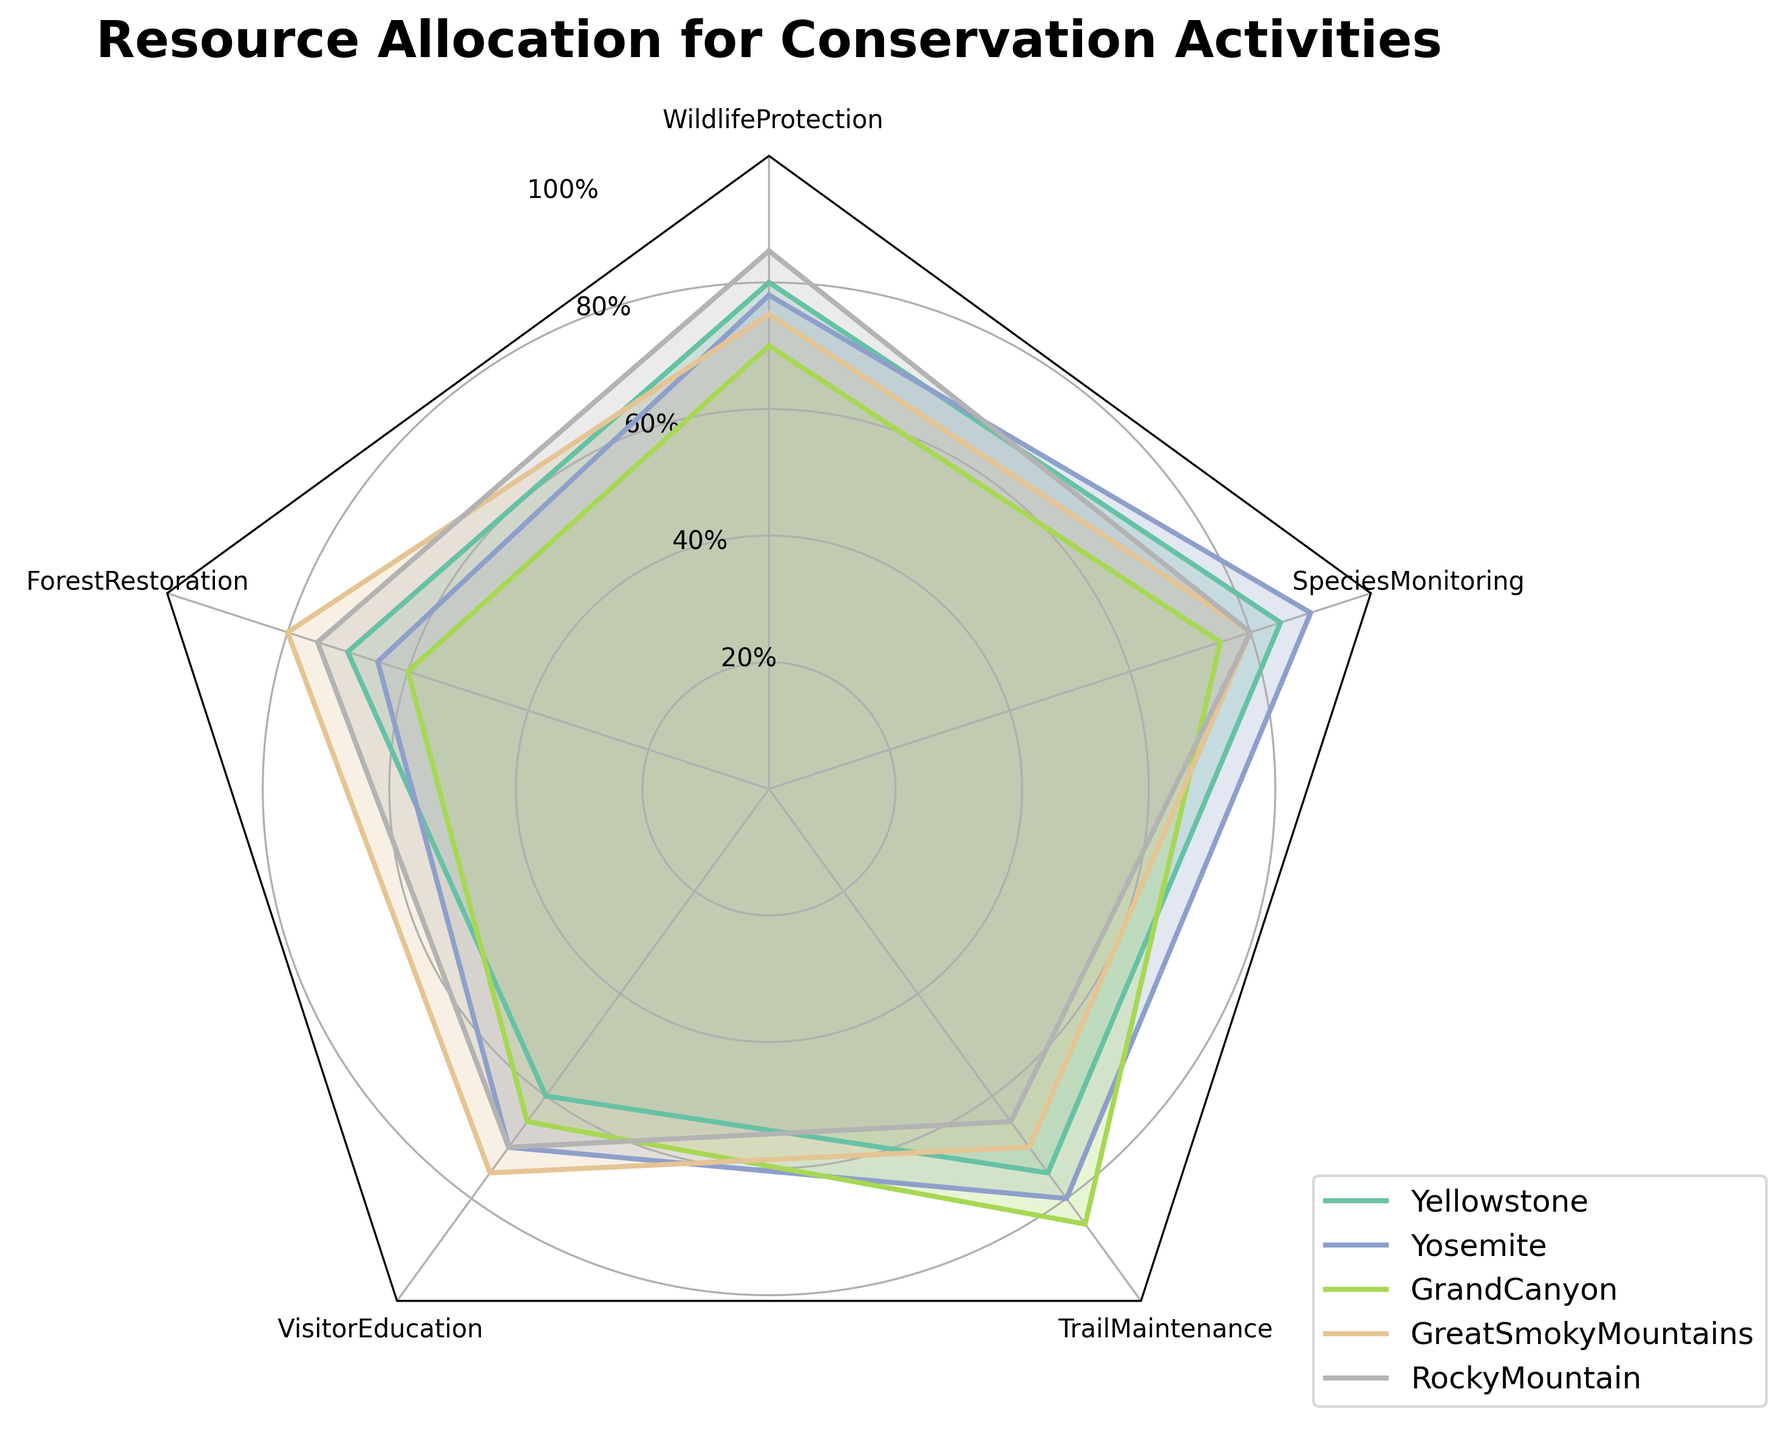How many activities are being allocated resources for conservation across the parks? The title indicates resource allocation for conservation activities and the radar chart has axes labeled with the activities being measured. We can count these axes to identify the number of activities.
Answer: 5 Which park has the highest allocation percentage for Wildlife Protection? By looking at the axis labeled Wildlife Protection, we can see which park's line extends the furthest out. This indicates the highest percentage allocated.
Answer: RockyMountain Which park has the lowest resource allocation for Trail Maintenance? By observing the axis labeled Trail Maintenance, we look for the shortest line among the parks, indicating the lowest percentage allocated for Trail Maintenance.
Answer: RockyMountain What is the range of allocation percentages for Visitor Education across all parks? To find the range, we identify the highest and lowest percentages for Visitor Education by monitoring where the respective axes extend for each park. The highest is from Yosemite (70%), and the lowest is from GrandCanyon (65%). The range is the difference between these values.
Answer: 5% Do all parks allocate more than 60% of their resources to Visitor Education? We check the Visitor Education axis for all parks and ensure all their lines extend beyond the 60% mark.
Answer: No Which two parks have the most similar resource allocation patterns overall? By comparing the shapes and sizes of the filled areas for each park, we look for two parks with closely aligned patterns on their radar charts.
Answer: GreatSmokyMountains and RockyMountain How does the resource allocation for Forest Restoration compare between Yellowstone and Yosemite? By examining the axes for Forest Restoration, we note the values for both Yellowstone (70%) and Yosemite (65%).
Answer: Yellowstone allocates more What is the average allocation percentage for Species Monitoring across all parks? Summing the percentages for Species Monitoring for all parks (85 + 90 + 75 + 80 + 80) and dividing by the number of parks (5) gives the average. (85 + 90 + 75 + 80 + 80) / 5 = 82
Answer: 82% Which activity shows the most variation in resource allocation across the parks? Identify the activity with the widest range from the radar chart by comparing the extents of the axes for all activities. Species Monitoring ranges from 75% to 90%, a difference of 15%, which might be the largest when compared to others.
Answer: Species Monitoring 